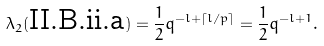Convert formula to latex. <formula><loc_0><loc_0><loc_500><loc_500>\lambda _ { 2 } ( \text {II.B.ii.a} ) & = \frac { 1 } { 2 } q ^ { - l + \lceil l / p \rceil } = \frac { 1 } { 2 } q ^ { - l + 1 } .</formula> 